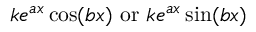<formula> <loc_0><loc_0><loc_500><loc_500>k e ^ { a x } \cos ( b x ) { o r } k e ^ { a x } \sin ( b x )</formula> 